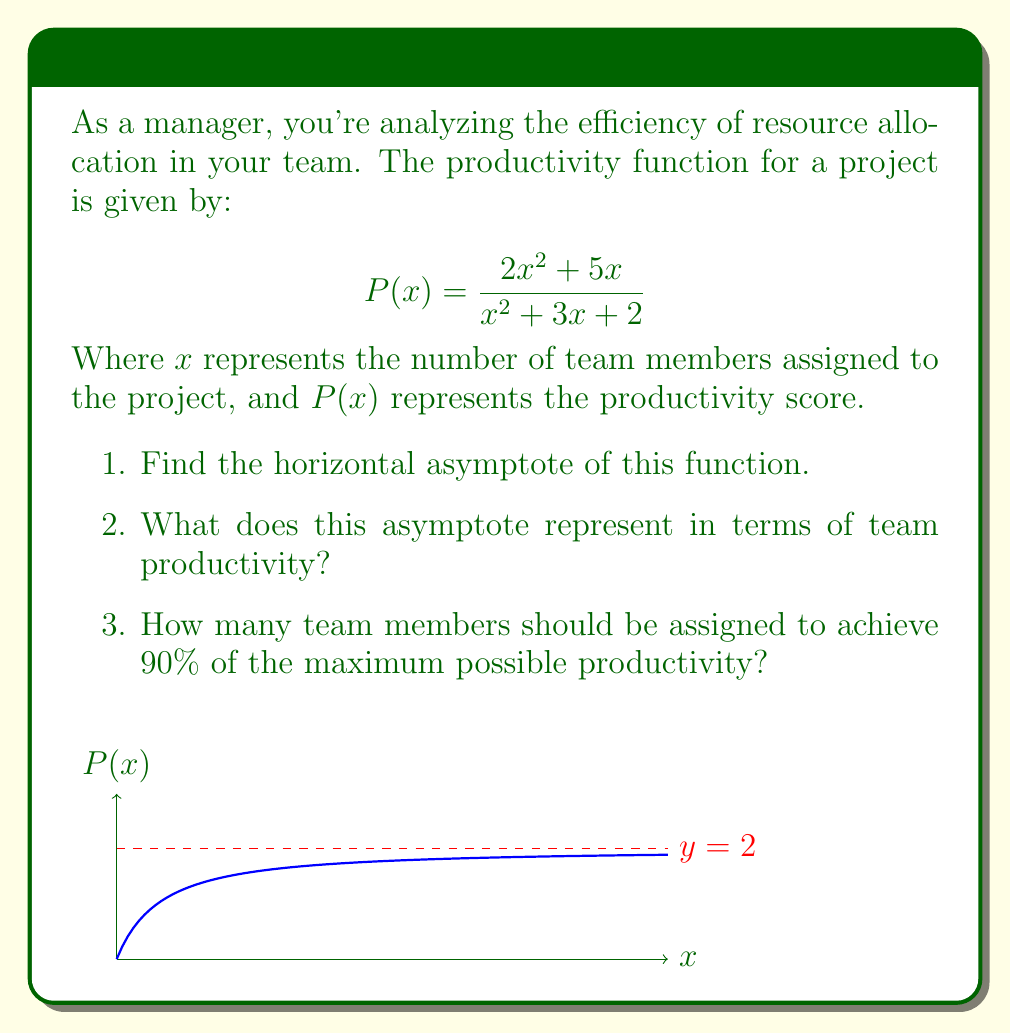Help me with this question. Let's approach this step-by-step:

1. To find the horizontal asymptote, we need to evaluate the limit of $P(x)$ as $x$ approaches infinity:

   $$\lim_{x \to \infty} P(x) = \lim_{x \to \infty} \frac{2x^2 + 5x}{x^2 + 3x + 2}$$

   Dividing both numerator and denominator by the highest power of $x$ (which is $x^2$):

   $$\lim_{x \to \infty} \frac{2 + 5/x}{1 + 3/x + 2/x^2} = \frac{2}{1} = 2$$

   Therefore, the horizontal asymptote is $y = 2$.

2. The horizontal asymptote represents the maximum possible productivity score that the team can achieve, regardless of how many more team members are added. In this case, the maximum productivity score is 2.

3. To find the number of team members needed for 90% of maximum productivity:

   90% of the maximum (2) is $0.9 \times 2 = 1.8$

   We need to solve the equation:

   $$\frac{2x^2 + 5x}{x^2 + 3x + 2} = 1.8$$

   Cross-multiplying:

   $$2x^2 + 5x = 1.8x^2 + 5.4x + 3.6$$

   Rearranging:

   $$0.2x^2 - 0.4x - 3.6 = 0$$

   Using the quadratic formula:

   $$x = \frac{0.4 \pm \sqrt{0.16 + 2.88}}{0.4} = \frac{0.4 \pm \sqrt{3.04}}{0.4}$$

   $$x \approx 4.95 \text{ or } -3.95$$

   Since we can't have negative team members, we round up to the nearest whole number: 5 team members.
Answer: 1) $y = 2$
2) Maximum achievable productivity score
3) 5 team members 